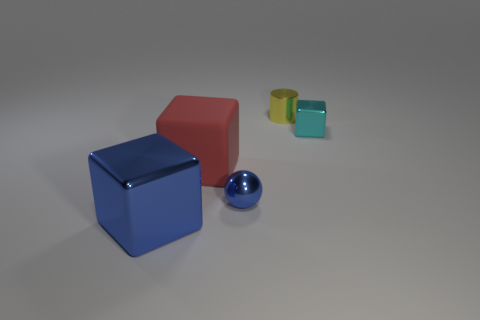What is the tiny thing that is in front of the cube behind the large red rubber thing made of?
Make the answer very short. Metal. There is a tiny thing that is both to the left of the small cyan shiny object and in front of the yellow shiny object; what material is it?
Provide a succinct answer. Metal. Is there another yellow shiny thing that has the same shape as the big metallic thing?
Your response must be concise. No. Are there any metallic cylinders on the left side of the tiny metallic thing that is in front of the tiny metal cube?
Keep it short and to the point. No. How many large cubes have the same material as the small yellow cylinder?
Ensure brevity in your answer.  1. Are any cyan metallic blocks visible?
Offer a very short reply. Yes. What number of other tiny balls have the same color as the tiny sphere?
Offer a very short reply. 0. Is the small cyan object made of the same material as the tiny object that is behind the cyan metallic thing?
Provide a succinct answer. Yes. Is the number of large shiny blocks that are behind the red matte object greater than the number of brown cylinders?
Provide a short and direct response. No. Are there any other things that are the same size as the red rubber block?
Ensure brevity in your answer.  Yes. 